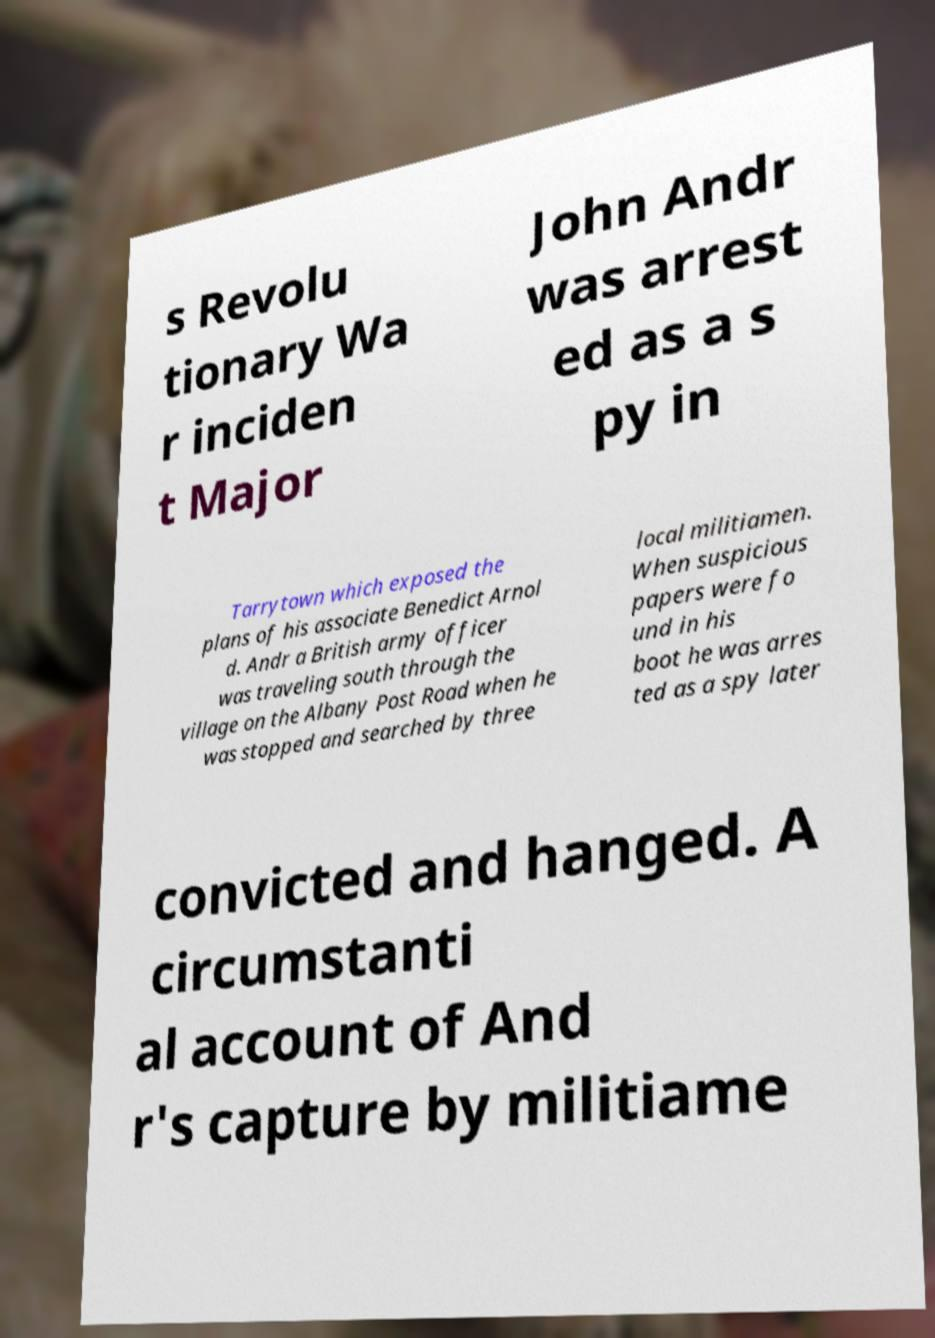Can you accurately transcribe the text from the provided image for me? s Revolu tionary Wa r inciden t Major John Andr was arrest ed as a s py in Tarrytown which exposed the plans of his associate Benedict Arnol d. Andr a British army officer was traveling south through the village on the Albany Post Road when he was stopped and searched by three local militiamen. When suspicious papers were fo und in his boot he was arres ted as a spy later convicted and hanged. A circumstanti al account of And r's capture by militiame 